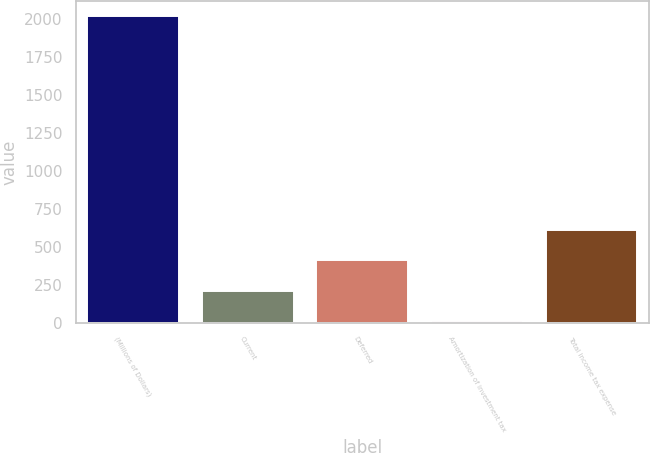<chart> <loc_0><loc_0><loc_500><loc_500><bar_chart><fcel>(Millions of Dollars)<fcel>Current<fcel>Deferred<fcel>Amortization of investment tax<fcel>Total income tax expense<nl><fcel>2015<fcel>209.6<fcel>410.2<fcel>9<fcel>610.8<nl></chart> 